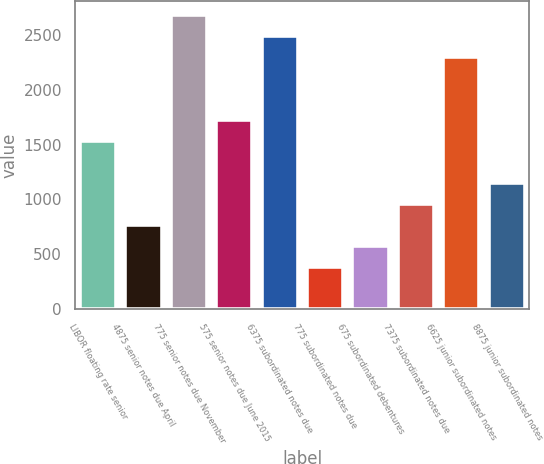Convert chart to OTSL. <chart><loc_0><loc_0><loc_500><loc_500><bar_chart><fcel>LIBOR floating rate senior<fcel>4875 senior notes due April<fcel>775 senior notes due November<fcel>575 senior notes due June 2015<fcel>6375 subordinated notes due<fcel>775 subordinated notes due<fcel>675 subordinated debentures<fcel>7375 subordinated notes due<fcel>6625 junior subordinated notes<fcel>8875 junior subordinated notes<nl><fcel>1532.4<fcel>769.2<fcel>2677.2<fcel>1723.2<fcel>2486.4<fcel>387.6<fcel>578.4<fcel>960<fcel>2295.6<fcel>1150.8<nl></chart> 